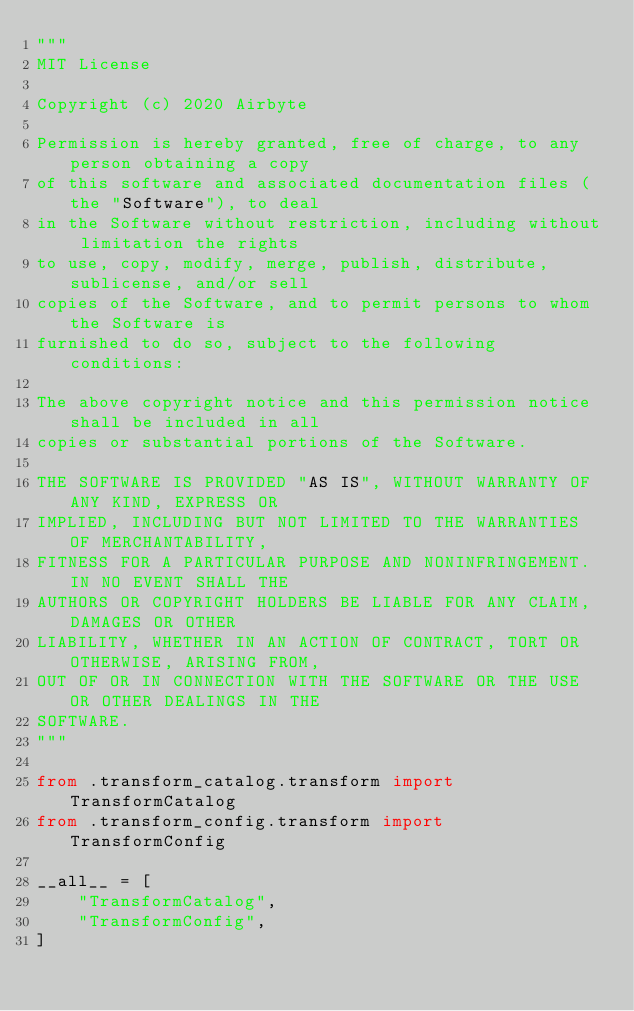<code> <loc_0><loc_0><loc_500><loc_500><_Python_>"""
MIT License

Copyright (c) 2020 Airbyte

Permission is hereby granted, free of charge, to any person obtaining a copy
of this software and associated documentation files (the "Software"), to deal
in the Software without restriction, including without limitation the rights
to use, copy, modify, merge, publish, distribute, sublicense, and/or sell
copies of the Software, and to permit persons to whom the Software is
furnished to do so, subject to the following conditions:

The above copyright notice and this permission notice shall be included in all
copies or substantial portions of the Software.

THE SOFTWARE IS PROVIDED "AS IS", WITHOUT WARRANTY OF ANY KIND, EXPRESS OR
IMPLIED, INCLUDING BUT NOT LIMITED TO THE WARRANTIES OF MERCHANTABILITY,
FITNESS FOR A PARTICULAR PURPOSE AND NONINFRINGEMENT. IN NO EVENT SHALL THE
AUTHORS OR COPYRIGHT HOLDERS BE LIABLE FOR ANY CLAIM, DAMAGES OR OTHER
LIABILITY, WHETHER IN AN ACTION OF CONTRACT, TORT OR OTHERWISE, ARISING FROM,
OUT OF OR IN CONNECTION WITH THE SOFTWARE OR THE USE OR OTHER DEALINGS IN THE
SOFTWARE.
"""

from .transform_catalog.transform import TransformCatalog
from .transform_config.transform import TransformConfig

__all__ = [
    "TransformCatalog",
    "TransformConfig",
]
</code> 